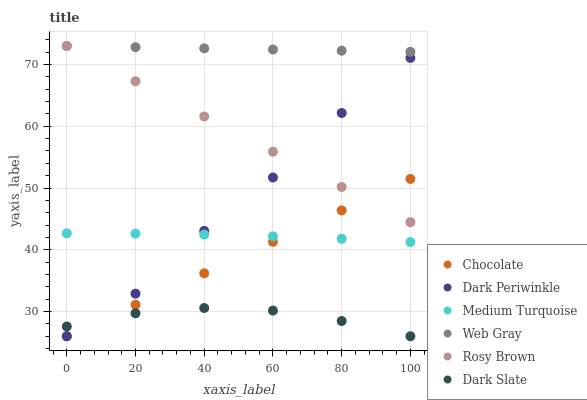Does Dark Slate have the minimum area under the curve?
Answer yes or no. Yes. Does Web Gray have the maximum area under the curve?
Answer yes or no. Yes. Does Rosy Brown have the minimum area under the curve?
Answer yes or no. No. Does Rosy Brown have the maximum area under the curve?
Answer yes or no. No. Is Chocolate the smoothest?
Answer yes or no. Yes. Is Dark Periwinkle the roughest?
Answer yes or no. Yes. Is Rosy Brown the smoothest?
Answer yes or no. No. Is Rosy Brown the roughest?
Answer yes or no. No. Does Chocolate have the lowest value?
Answer yes or no. Yes. Does Rosy Brown have the lowest value?
Answer yes or no. No. Does Rosy Brown have the highest value?
Answer yes or no. Yes. Does Chocolate have the highest value?
Answer yes or no. No. Is Dark Slate less than Rosy Brown?
Answer yes or no. Yes. Is Rosy Brown greater than Dark Slate?
Answer yes or no. Yes. Does Medium Turquoise intersect Dark Periwinkle?
Answer yes or no. Yes. Is Medium Turquoise less than Dark Periwinkle?
Answer yes or no. No. Is Medium Turquoise greater than Dark Periwinkle?
Answer yes or no. No. Does Dark Slate intersect Rosy Brown?
Answer yes or no. No. 